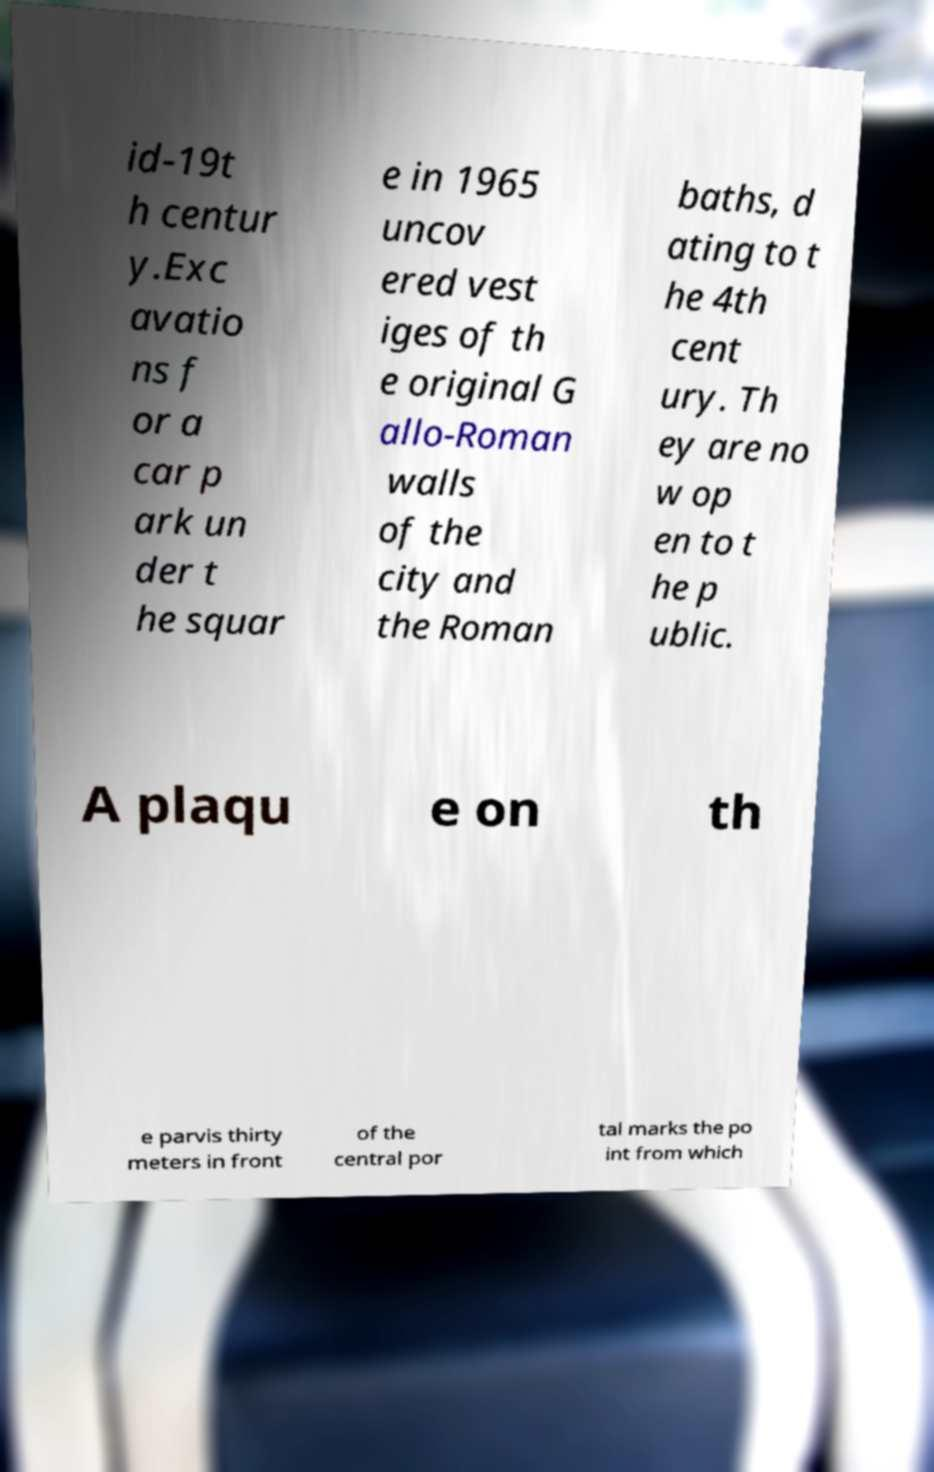Please identify and transcribe the text found in this image. id-19t h centur y.Exc avatio ns f or a car p ark un der t he squar e in 1965 uncov ered vest iges of th e original G allo-Roman walls of the city and the Roman baths, d ating to t he 4th cent ury. Th ey are no w op en to t he p ublic. A plaqu e on th e parvis thirty meters in front of the central por tal marks the po int from which 